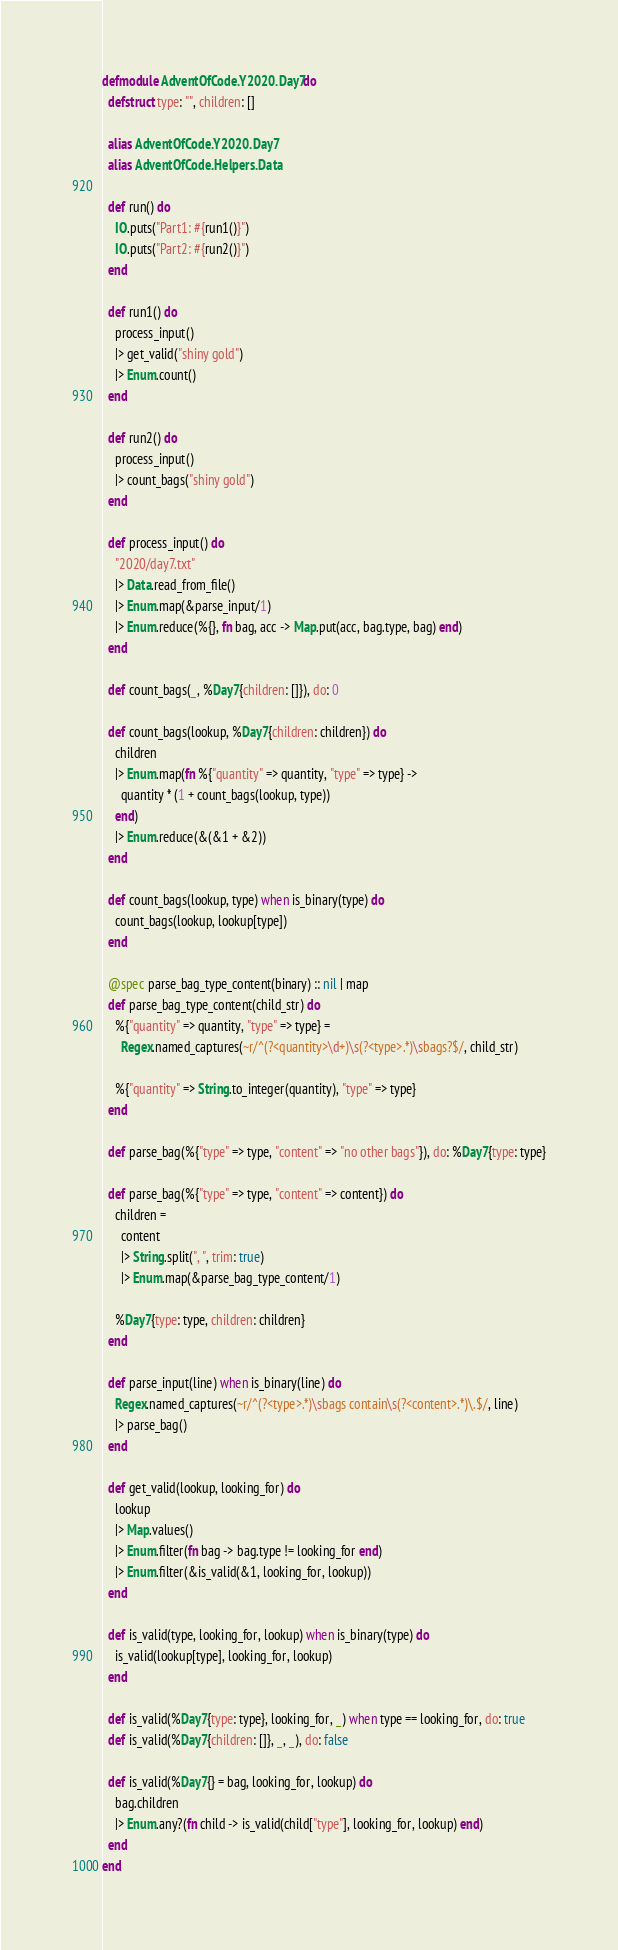Convert code to text. <code><loc_0><loc_0><loc_500><loc_500><_Elixir_>defmodule AdventOfCode.Y2020.Day7 do
  defstruct type: "", children: []

  alias AdventOfCode.Y2020.Day7
  alias AdventOfCode.Helpers.Data

  def run() do
    IO.puts("Part1: #{run1()}")
    IO.puts("Part2: #{run2()}")
  end

  def run1() do
    process_input()
    |> get_valid("shiny gold")
    |> Enum.count()
  end

  def run2() do
    process_input()
    |> count_bags("shiny gold")
  end

  def process_input() do
    "2020/day7.txt"
    |> Data.read_from_file()
    |> Enum.map(&parse_input/1)
    |> Enum.reduce(%{}, fn bag, acc -> Map.put(acc, bag.type, bag) end)
  end

  def count_bags(_, %Day7{children: []}), do: 0

  def count_bags(lookup, %Day7{children: children}) do
    children
    |> Enum.map(fn %{"quantity" => quantity, "type" => type} ->
      quantity * (1 + count_bags(lookup, type))
    end)
    |> Enum.reduce(&(&1 + &2))
  end

  def count_bags(lookup, type) when is_binary(type) do
    count_bags(lookup, lookup[type])
  end

  @spec parse_bag_type_content(binary) :: nil | map
  def parse_bag_type_content(child_str) do
    %{"quantity" => quantity, "type" => type} =
      Regex.named_captures(~r/^(?<quantity>\d+)\s(?<type>.*)\sbags?$/, child_str)

    %{"quantity" => String.to_integer(quantity), "type" => type}
  end

  def parse_bag(%{"type" => type, "content" => "no other bags"}), do: %Day7{type: type}

  def parse_bag(%{"type" => type, "content" => content}) do
    children =
      content
      |> String.split(", ", trim: true)
      |> Enum.map(&parse_bag_type_content/1)

    %Day7{type: type, children: children}
  end

  def parse_input(line) when is_binary(line) do
    Regex.named_captures(~r/^(?<type>.*)\sbags contain\s(?<content>.*)\.$/, line)
    |> parse_bag()
  end

  def get_valid(lookup, looking_for) do
    lookup
    |> Map.values()
    |> Enum.filter(fn bag -> bag.type != looking_for end)
    |> Enum.filter(&is_valid(&1, looking_for, lookup))
  end

  def is_valid(type, looking_for, lookup) when is_binary(type) do
    is_valid(lookup[type], looking_for, lookup)
  end

  def is_valid(%Day7{type: type}, looking_for, _) when type == looking_for, do: true
  def is_valid(%Day7{children: []}, _, _), do: false

  def is_valid(%Day7{} = bag, looking_for, lookup) do
    bag.children
    |> Enum.any?(fn child -> is_valid(child["type"], looking_for, lookup) end)
  end
end
</code> 